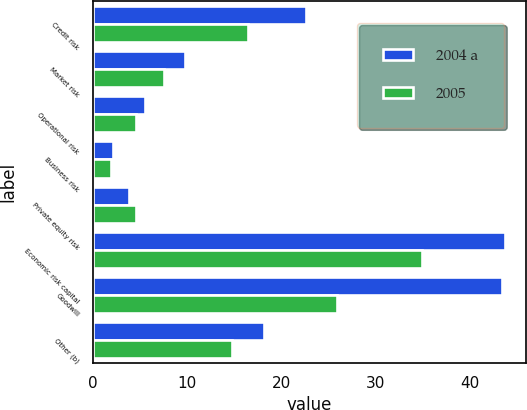Convert chart to OTSL. <chart><loc_0><loc_0><loc_500><loc_500><stacked_bar_chart><ecel><fcel>Credit risk<fcel>Market risk<fcel>Operational risk<fcel>Business risk<fcel>Private equity risk<fcel>Economic risk capital<fcel>Goodwill<fcel>Other (b)<nl><fcel>2004 a<fcel>22.6<fcel>9.8<fcel>5.5<fcel>2.1<fcel>3.8<fcel>43.8<fcel>43.5<fcel>18.2<nl><fcel>2005<fcel>16.5<fcel>7.5<fcel>4.5<fcel>1.9<fcel>4.5<fcel>34.9<fcel>25.9<fcel>14.8<nl></chart> 